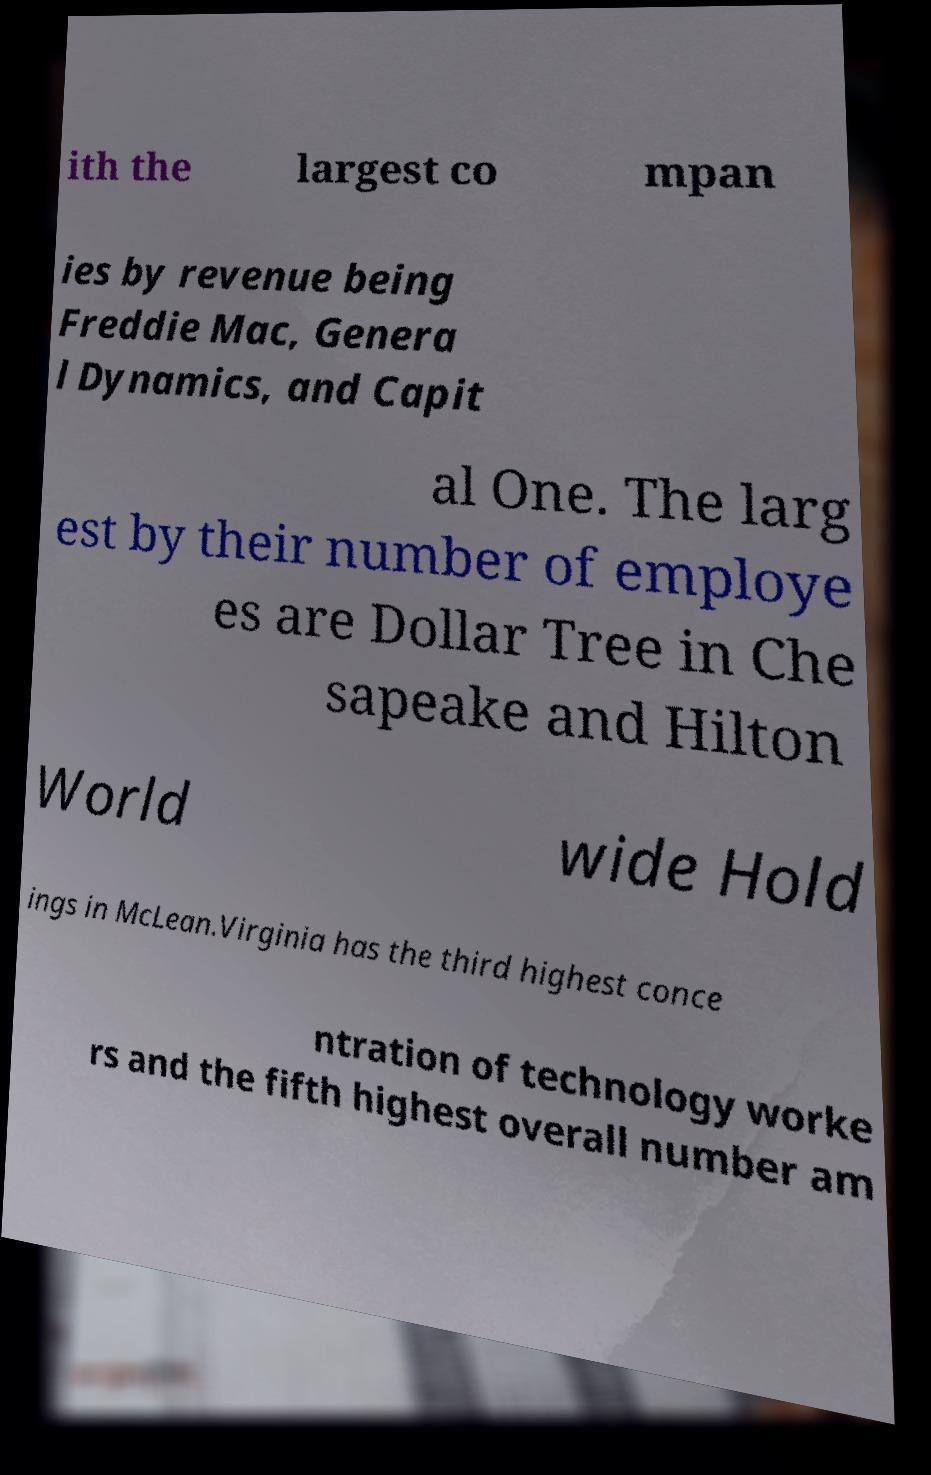What messages or text are displayed in this image? I need them in a readable, typed format. ith the largest co mpan ies by revenue being Freddie Mac, Genera l Dynamics, and Capit al One. The larg est by their number of employe es are Dollar Tree in Che sapeake and Hilton World wide Hold ings in McLean.Virginia has the third highest conce ntration of technology worke rs and the fifth highest overall number am 